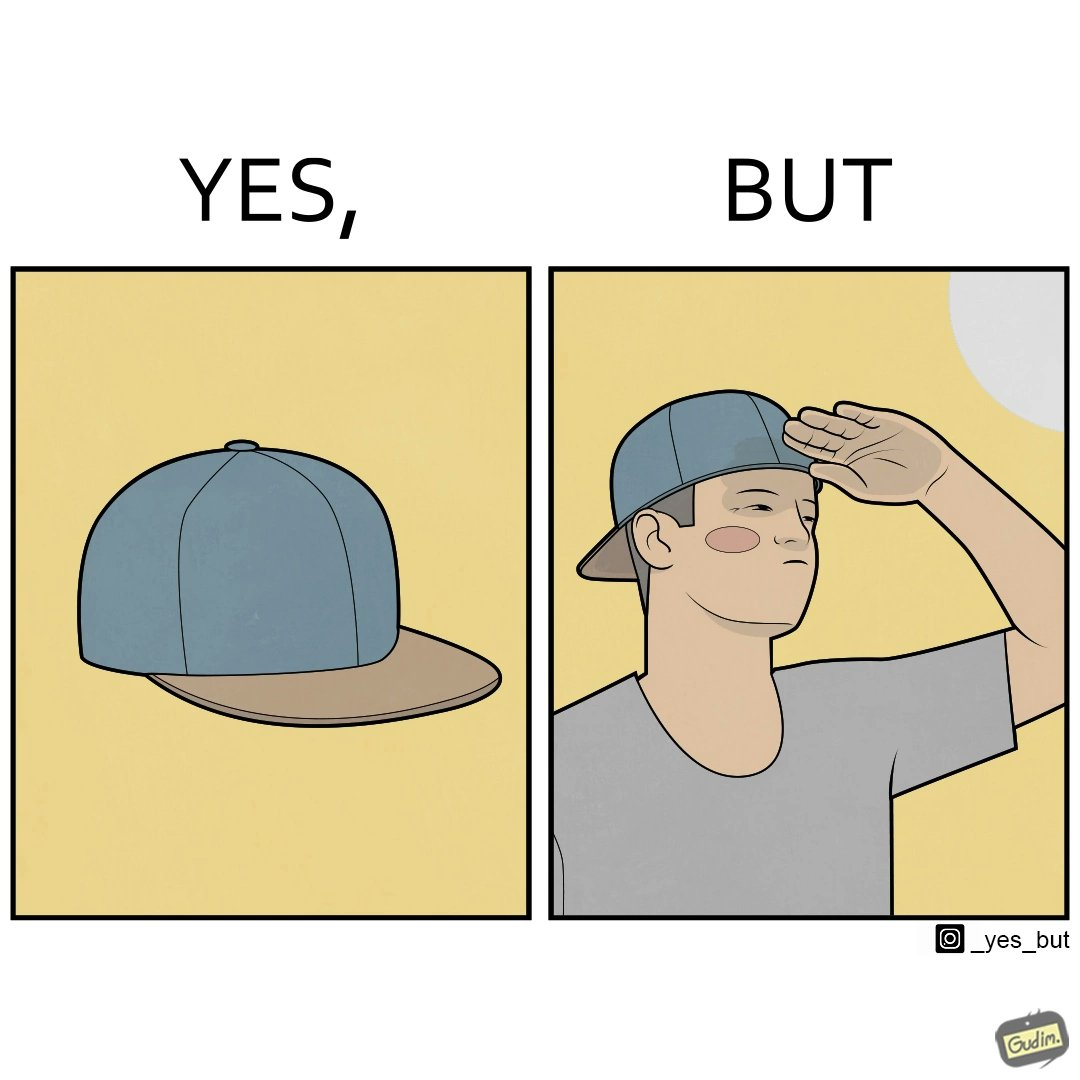Describe what you see in the left and right parts of this image. In the left part of the image: A regular ordinary cap that is meant to shield one's eyes from the sun In the right part of the image: A person wearing a cap backwards to look stylish. Sun is very brightly shining on their face, making them uncomfortable so they squint their eyes and use their hand to shadow their face from the sun. 